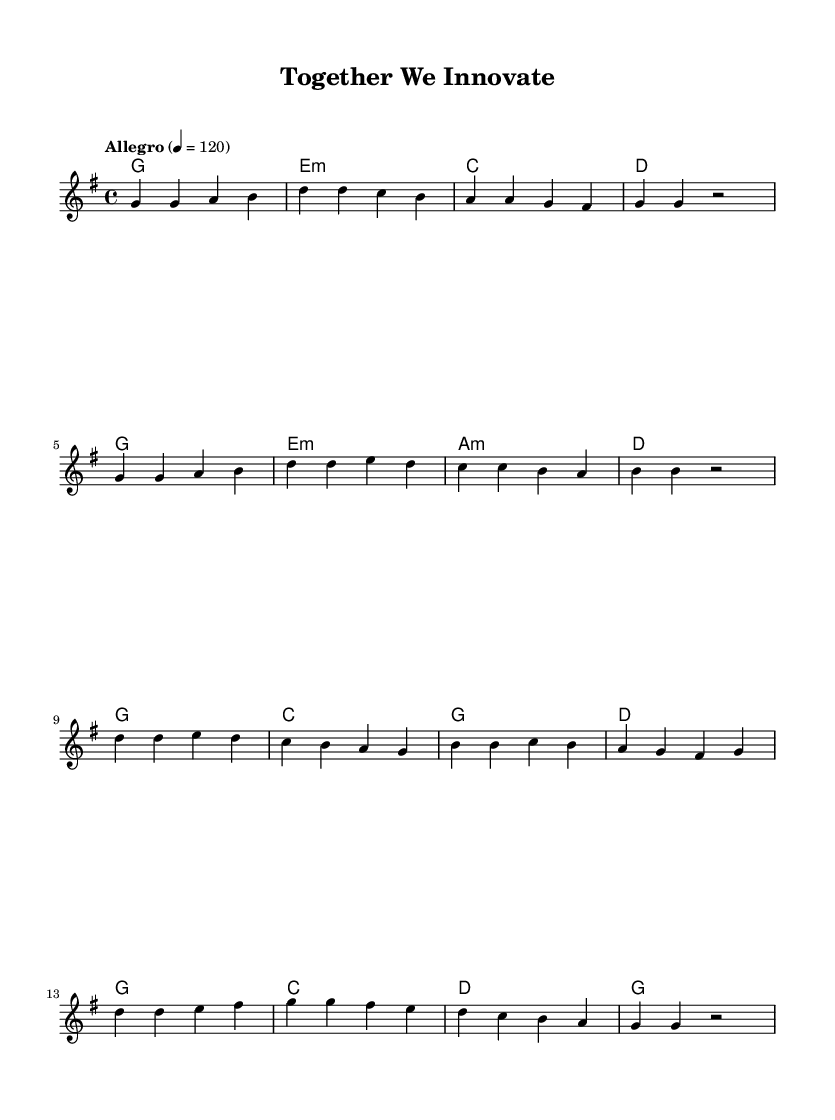What is the key signature of this music? The key signature is G major, which contains one sharp (F#). This is indicated at the beginning of the staff in the sheet music.
Answer: G major What is the time signature of the music? The time signature is 4/4, meaning there are four beats in each measure, and the quarter note gets one beat. This is shown at the beginning of the music right after the key signature.
Answer: 4/4 What is the tempo marking for this piece? The tempo marking indicates "Allegro," which is a term commonly used in music to denote a fast, lively pace. It is found at the beginning of the score before the musical phrases start.
Answer: Allegro How many measures are in the verse section? The verse section consists of two sections of 4 measures each, totaling 8 measures. Count the individual measures notated in the melody for verification.
Answer: 8 What progression of harmonies is used in the chorus? The harmonies in the chorus follow a G-C-G-D progression. This can be determined by examining the chord symbols written above the melody for the chorus section.
Answer: G-C-G-D Which musical form does this anthem predominantly feature? The anthem predominantly features a verse-chorus structure, which is common in K-Pop songs, denoting the arrangement of the melody and lyrics into repeating verses and a central chorus. This can be observed in the order of sections presented in the sheet music.
Answer: Verse-Chorus What mood is conveyed through the tempo and the key signature? The combination of a fast tempo (Allegro) and an uplifting key signature (G major) generally conveys a joyful and energetic mood, suitable for motivational themes focused on teamwork. The fast tempo adds to the uplifting feel, appropriate for an anthem.
Answer: Joyful-Energetic 